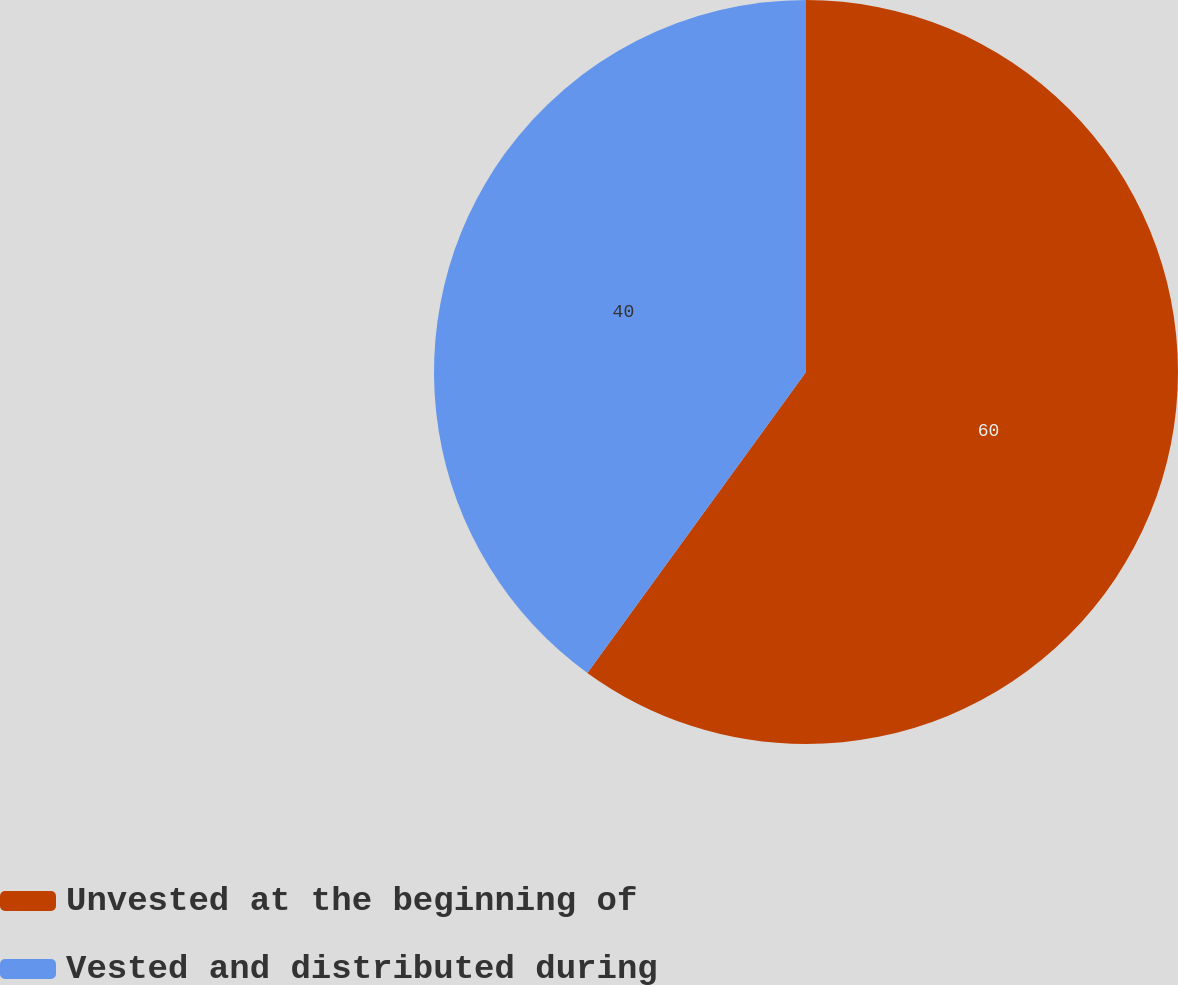<chart> <loc_0><loc_0><loc_500><loc_500><pie_chart><fcel>Unvested at the beginning of<fcel>Vested and distributed during<nl><fcel>60.0%<fcel>40.0%<nl></chart> 